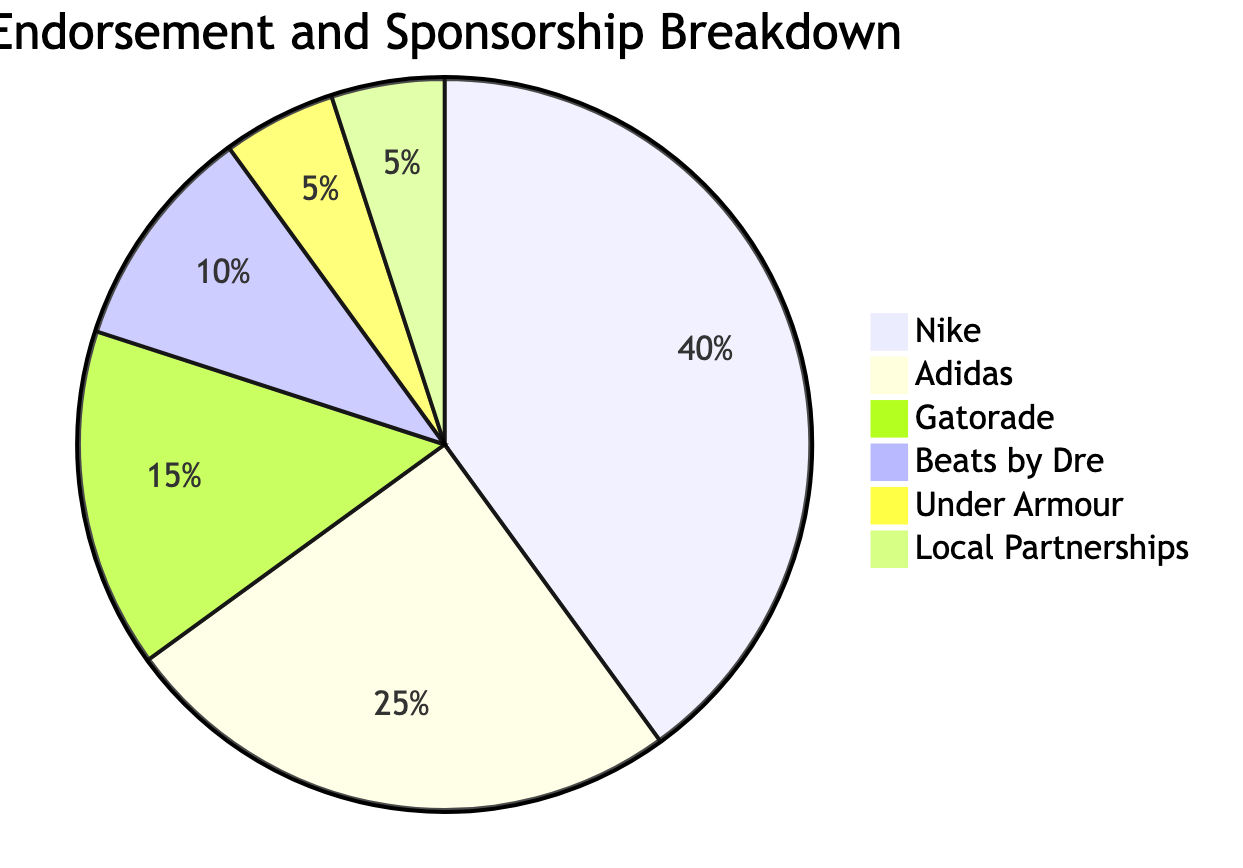What's the percentage of income from Nike endorsements? The pie chart indicates that Nike accounts for 40% of the total endorsement income, as shown by its designated section in the diagram.
Answer: 40% How many different brands or categories are represented in the diagram? The diagram displays six distinct brands or categories, each represented by a separate section in the pie chart.
Answer: 6 Which brand has the lowest percentage of income from endorsements? Under Armour and Local Partnerships both represent 5% each, which is the smallest section of the pie chart, indicating they have the lowest percentage of income compared to the other brands.
Answer: Under Armour, Local Partnerships What percentage of the total endorsements do Adidas and Gatorade combined represent? Adding the percentages of Adidas (25%) and Gatorade (15%) together results in a combined total of 40% of the endorsement income.
Answer: 40% Which brand accounts for more than 15% of the income? Nike (40%) and Adidas (25%) are the only brands that exceed 15%, as indicated by their respective sections in the pie chart.
Answer: Nike, Adidas What is the proportion of income from Beats by Dre compared to Gatorade? Beats by Dre accounts for 10% while Gatorade accounts for 15%. Therefore, Gatorade has a higher proportion than Beats by Dre, specifically 5% more.
Answer: Gatorade How does the endorsement income from local partnerships compare to that from Adidas? Local Partnerships account for 5%, whereas Adidas accounts for 25%. Thus, endorsements from Adidas are significantly higher, specifically 20% more than Local Partnerships.
Answer: Higher by 20% What visual representation is used to show the endorsement income distribution? The diagram uses a pie chart to illustrate the distribution of income from various endorsements and sponsorships.
Answer: Pie chart 